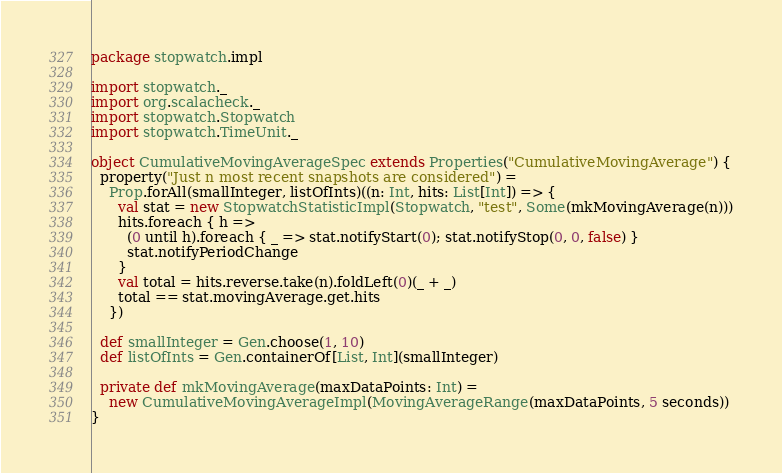<code> <loc_0><loc_0><loc_500><loc_500><_Scala_>package stopwatch.impl

import stopwatch._
import org.scalacheck._
import stopwatch.Stopwatch
import stopwatch.TimeUnit._

object CumulativeMovingAverageSpec extends Properties("CumulativeMovingAverage") {
  property("Just n most recent snapshots are considered") = 
    Prop.forAll(smallInteger, listOfInts)((n: Int, hits: List[Int]) => { 
      val stat = new StopwatchStatisticImpl(Stopwatch, "test", Some(mkMovingAverage(n)))
      hits.foreach { h =>
        (0 until h).foreach { _ => stat.notifyStart(0); stat.notifyStop(0, 0, false) }
        stat.notifyPeriodChange
      }
      val total = hits.reverse.take(n).foldLeft(0)(_ + _)
      total == stat.movingAverage.get.hits
    })

  def smallInteger = Gen.choose(1, 10)
  def listOfInts = Gen.containerOf[List, Int](smallInteger)

  private def mkMovingAverage(maxDataPoints: Int) = 
    new CumulativeMovingAverageImpl(MovingAverageRange(maxDataPoints, 5 seconds))
}
</code> 